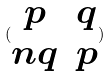Convert formula to latex. <formula><loc_0><loc_0><loc_500><loc_500>( \begin{matrix} p & q \\ n q & p \end{matrix} )</formula> 